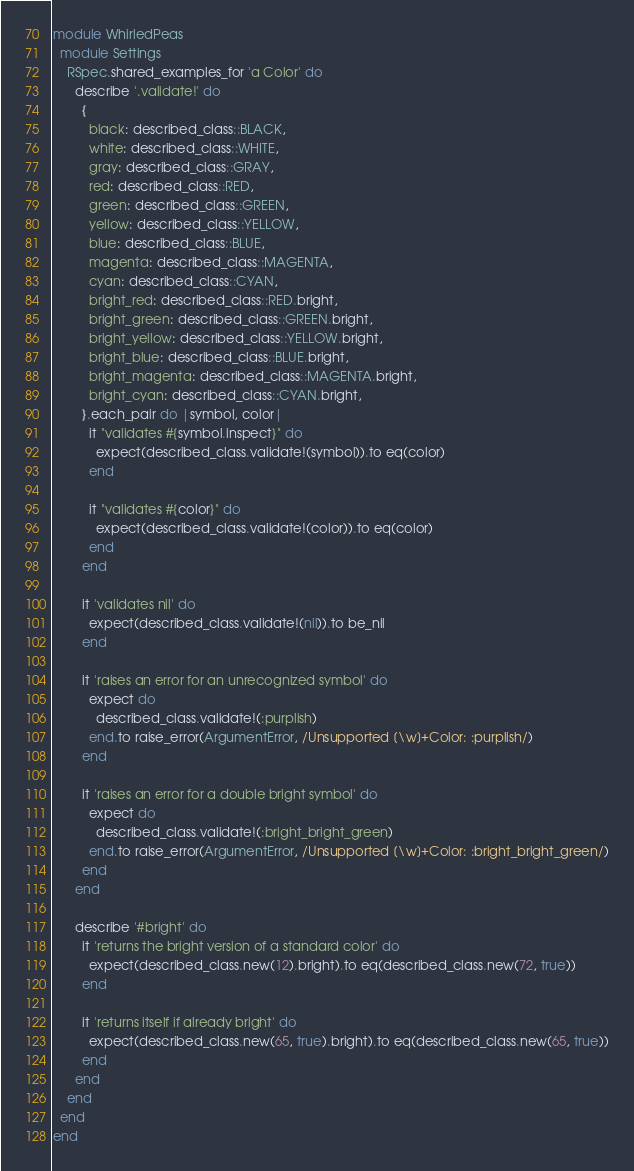Convert code to text. <code><loc_0><loc_0><loc_500><loc_500><_Ruby_>module WhirledPeas
  module Settings
    RSpec.shared_examples_for 'a Color' do
      describe '.validate!' do
        {
          black: described_class::BLACK,
          white: described_class::WHITE,
          gray: described_class::GRAY,
          red: described_class::RED,
          green: described_class::GREEN,
          yellow: described_class::YELLOW,
          blue: described_class::BLUE,
          magenta: described_class::MAGENTA,
          cyan: described_class::CYAN,
          bright_red: described_class::RED.bright,
          bright_green: described_class::GREEN.bright,
          bright_yellow: described_class::YELLOW.bright,
          bright_blue: described_class::BLUE.bright,
          bright_magenta: described_class::MAGENTA.bright,
          bright_cyan: described_class::CYAN.bright,
        }.each_pair do |symbol, color|
          it "validates #{symbol.inspect}" do
            expect(described_class.validate!(symbol)).to eq(color)
          end

          it "validates #{color}" do
            expect(described_class.validate!(color)).to eq(color)
          end
        end

        it 'validates nil' do
          expect(described_class.validate!(nil)).to be_nil
        end

        it 'raises an error for an unrecognized symbol' do
          expect do
            described_class.validate!(:purplish)
          end.to raise_error(ArgumentError, /Unsupported [\w]+Color: :purplish/)
        end

        it 'raises an error for a double bright symbol' do
          expect do
            described_class.validate!(:bright_bright_green)
          end.to raise_error(ArgumentError, /Unsupported [\w]+Color: :bright_bright_green/)
        end
      end

      describe '#bright' do
        it 'returns the bright version of a standard color' do
          expect(described_class.new(12).bright).to eq(described_class.new(72, true))
        end

        it 'returns itself if already bright' do
          expect(described_class.new(65, true).bright).to eq(described_class.new(65, true))
        end
      end
    end
  end
end
</code> 